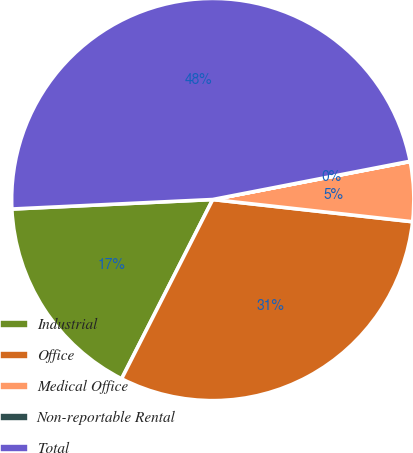Convert chart. <chart><loc_0><loc_0><loc_500><loc_500><pie_chart><fcel>Industrial<fcel>Office<fcel>Medical Office<fcel>Non-reportable Rental<fcel>Total<nl><fcel>16.76%<fcel>30.72%<fcel>4.79%<fcel>0.02%<fcel>47.7%<nl></chart> 